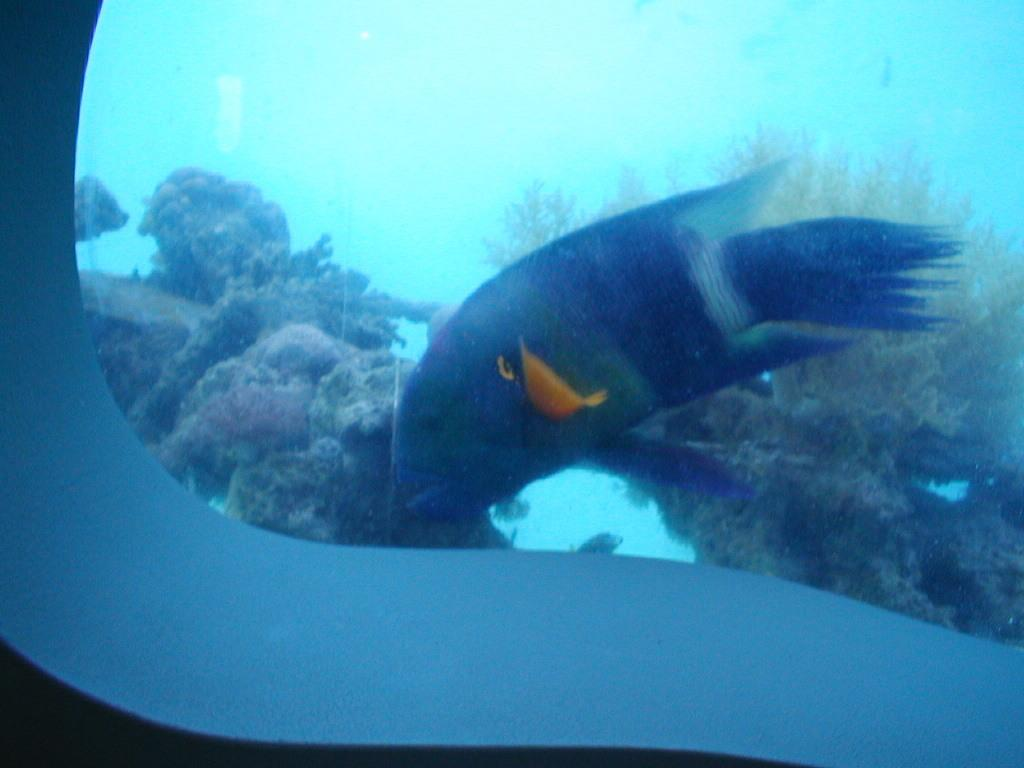What type of animal is present in the image? There is a blue colored fish in the image. What else can be seen in the image besides the fish? There are marine plants in the image. What is the primary setting of the image? The water is visible in the image. Is there a volcano visible in the image? No, there is no volcano present in the image. 